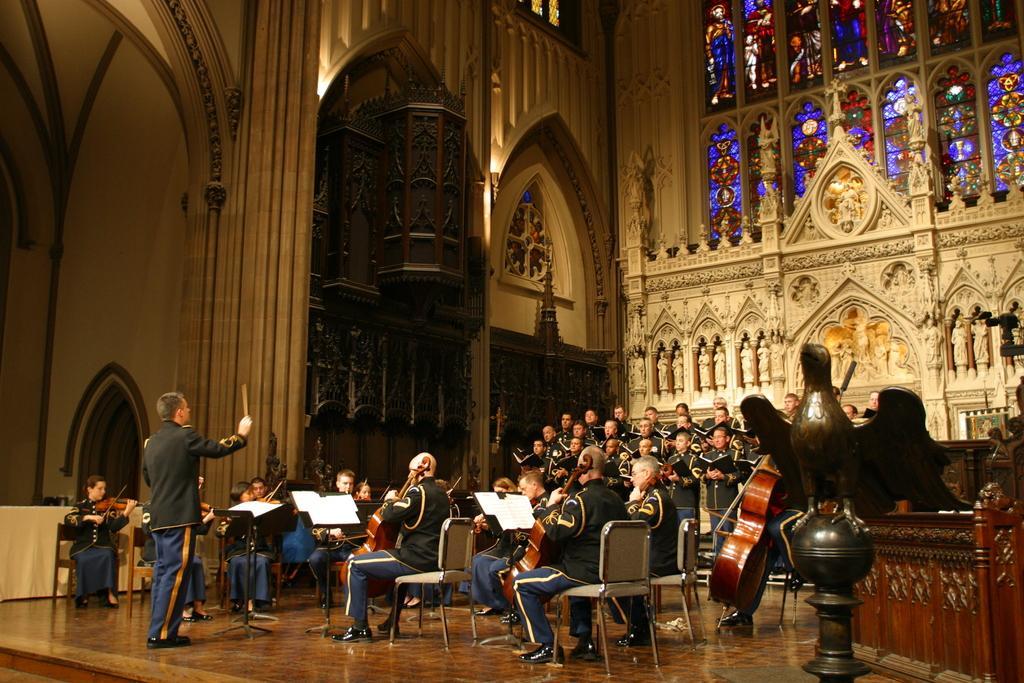Please provide a concise description of this image. In this image I can see a group of people facing towards the person standing on the left hand facing towards the them and I can see the building as a background which is well carved.  